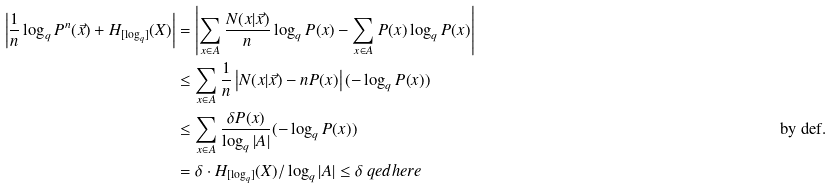<formula> <loc_0><loc_0><loc_500><loc_500>\left | \frac { 1 } { n } \log _ { q } P ^ { n } ( \vec { x } ) + H _ { [ \log _ { q } ] } ( X ) \right | & = \left | \sum _ { x \in A } \frac { N ( x | \vec { x } ) } { n } \log _ { q } P ( x ) - \sum _ { x \in A } P ( x ) \log _ { q } P ( x ) \right | \\ & \leq \sum _ { x \in A } \frac { 1 } { n } \left | N ( x | \vec { x } ) - n P ( x ) \right | ( - \log _ { q } P ( x ) ) \\ & \leq \sum _ { x \in A } \frac { \delta P ( x ) } { \log _ { q } | A | } ( - \log _ { q } P ( x ) ) & & \text {by def.} \\ & = \delta \cdot H _ { [ \log _ { q } ] } ( X ) / \log _ { q } | A | \leq \delta \ q e d h e r e</formula> 